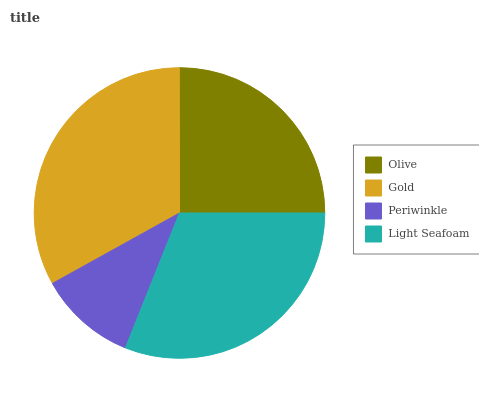Is Periwinkle the minimum?
Answer yes or no. Yes. Is Gold the maximum?
Answer yes or no. Yes. Is Gold the minimum?
Answer yes or no. No. Is Periwinkle the maximum?
Answer yes or no. No. Is Gold greater than Periwinkle?
Answer yes or no. Yes. Is Periwinkle less than Gold?
Answer yes or no. Yes. Is Periwinkle greater than Gold?
Answer yes or no. No. Is Gold less than Periwinkle?
Answer yes or no. No. Is Light Seafoam the high median?
Answer yes or no. Yes. Is Olive the low median?
Answer yes or no. Yes. Is Olive the high median?
Answer yes or no. No. Is Periwinkle the low median?
Answer yes or no. No. 